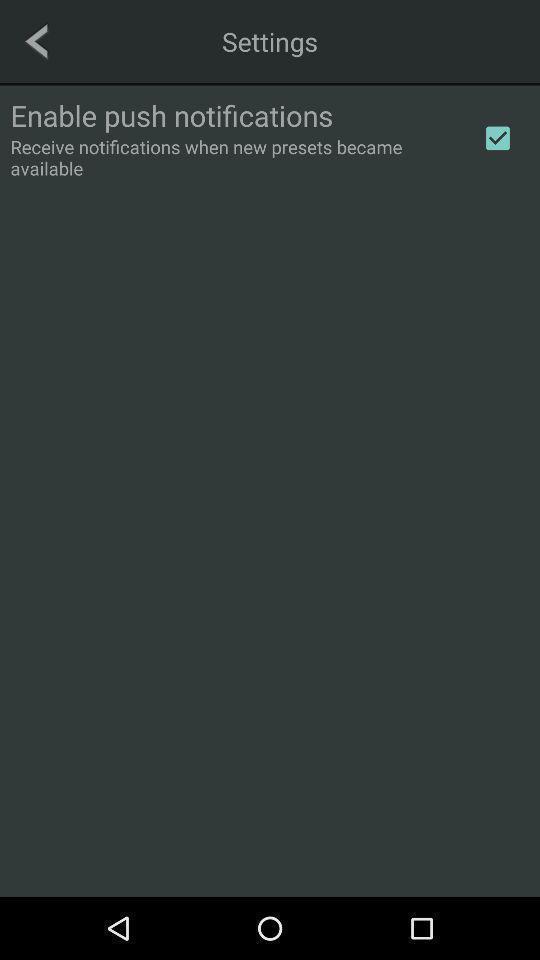Summarize the main components in this picture. Settings page of the notifications. 